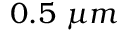Convert formula to latex. <formula><loc_0><loc_0><loc_500><loc_500>0 . 5 \ \mu m</formula> 